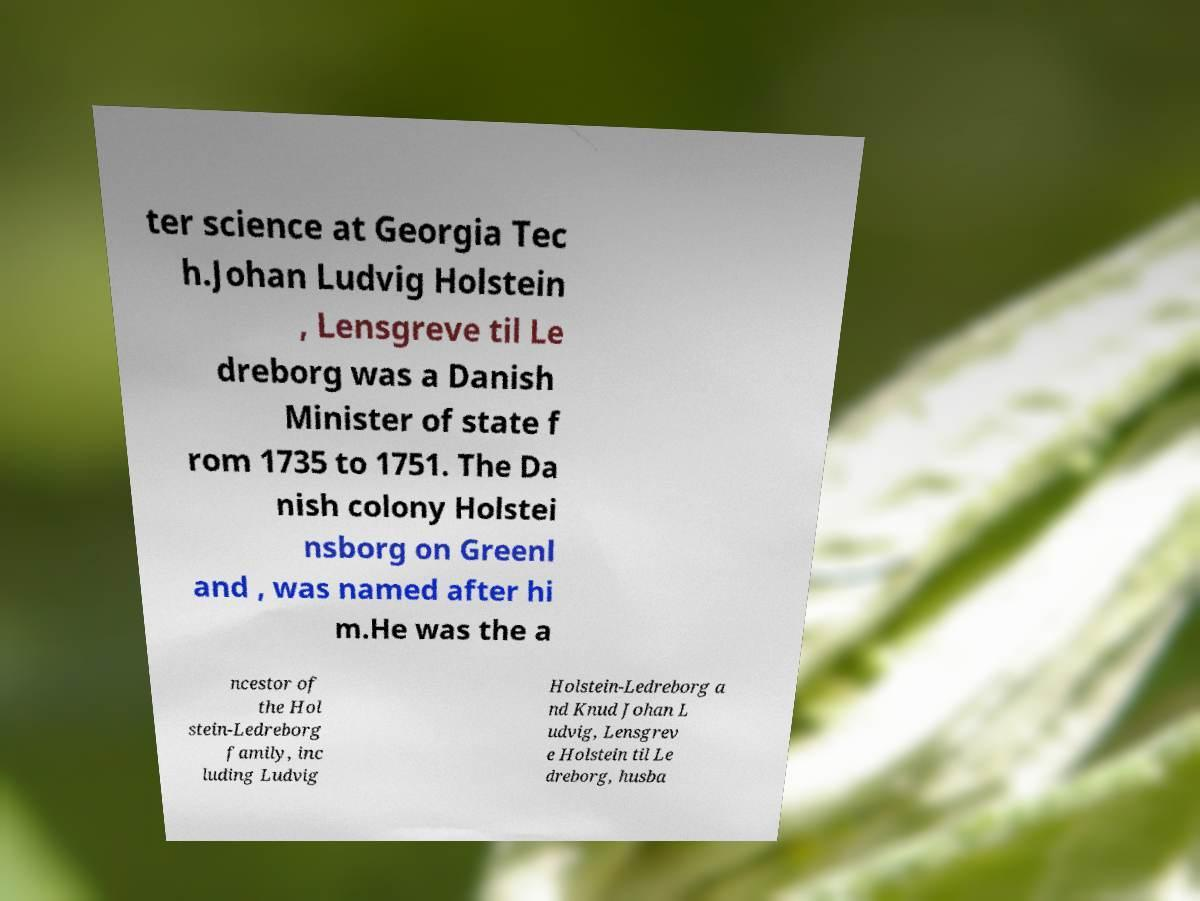Could you extract and type out the text from this image? ter science at Georgia Tec h.Johan Ludvig Holstein , Lensgreve til Le dreborg was a Danish Minister of state f rom 1735 to 1751. The Da nish colony Holstei nsborg on Greenl and , was named after hi m.He was the a ncestor of the Hol stein-Ledreborg family, inc luding Ludvig Holstein-Ledreborg a nd Knud Johan L udvig, Lensgrev e Holstein til Le dreborg, husba 